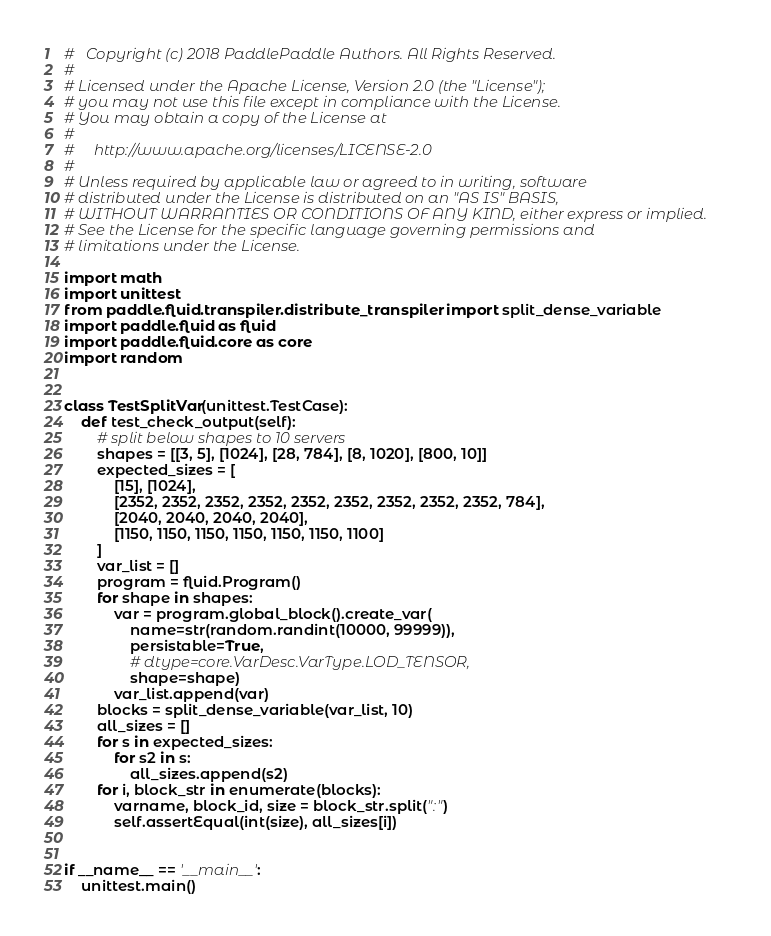Convert code to text. <code><loc_0><loc_0><loc_500><loc_500><_Python_>#   Copyright (c) 2018 PaddlePaddle Authors. All Rights Reserved.
#
# Licensed under the Apache License, Version 2.0 (the "License");
# you may not use this file except in compliance with the License.
# You may obtain a copy of the License at
#
#     http://www.apache.org/licenses/LICENSE-2.0
#
# Unless required by applicable law or agreed to in writing, software
# distributed under the License is distributed on an "AS IS" BASIS,
# WITHOUT WARRANTIES OR CONDITIONS OF ANY KIND, either express or implied.
# See the License for the specific language governing permissions and
# limitations under the License.

import math
import unittest
from paddle.fluid.transpiler.distribute_transpiler import split_dense_variable
import paddle.fluid as fluid
import paddle.fluid.core as core
import random


class TestSplitVar(unittest.TestCase):
    def test_check_output(self):
        # split below shapes to 10 servers
        shapes = [[3, 5], [1024], [28, 784], [8, 1020], [800, 10]]
        expected_sizes = [
            [15], [1024],
            [2352, 2352, 2352, 2352, 2352, 2352, 2352, 2352, 2352, 784],
            [2040, 2040, 2040, 2040],
            [1150, 1150, 1150, 1150, 1150, 1150, 1100]
        ]
        var_list = []
        program = fluid.Program()
        for shape in shapes:
            var = program.global_block().create_var(
                name=str(random.randint(10000, 99999)),
                persistable=True,
                # dtype=core.VarDesc.VarType.LOD_TENSOR,
                shape=shape)
            var_list.append(var)
        blocks = split_dense_variable(var_list, 10)
        all_sizes = []
        for s in expected_sizes:
            for s2 in s:
                all_sizes.append(s2)
        for i, block_str in enumerate(blocks):
            varname, block_id, size = block_str.split(":")
            self.assertEqual(int(size), all_sizes[i])


if __name__ == '__main__':
    unittest.main()
</code> 